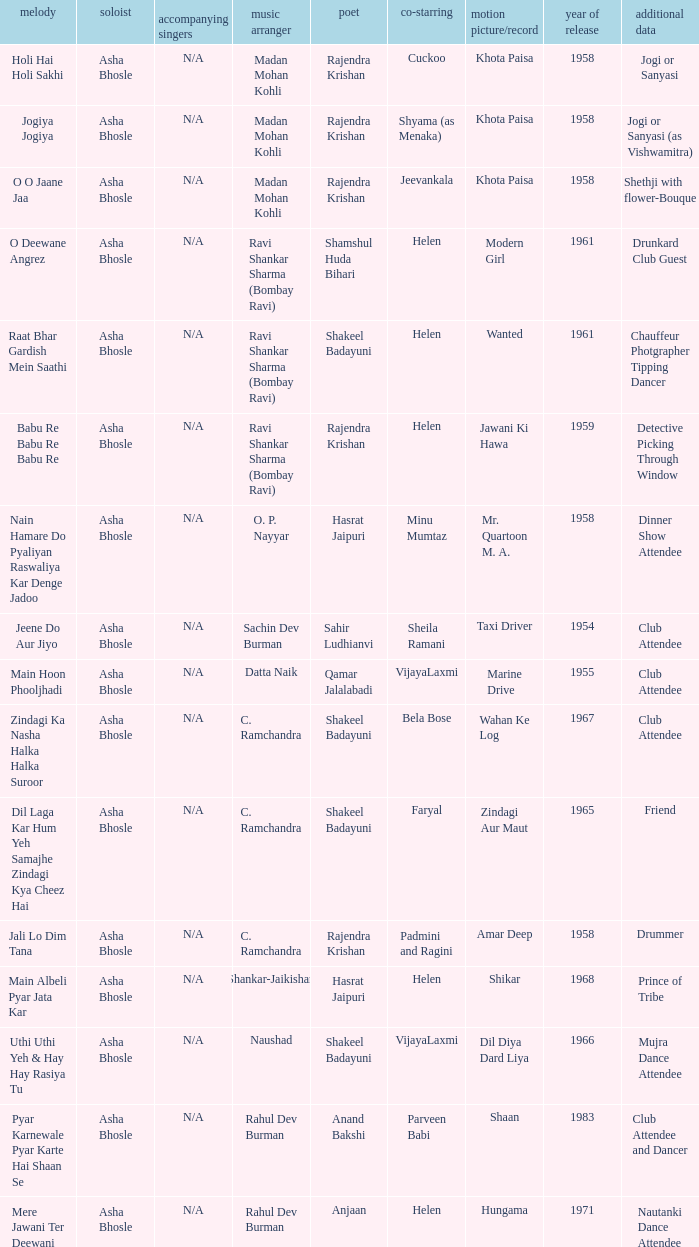What year did Naushad Direct the Music? 1966.0. 